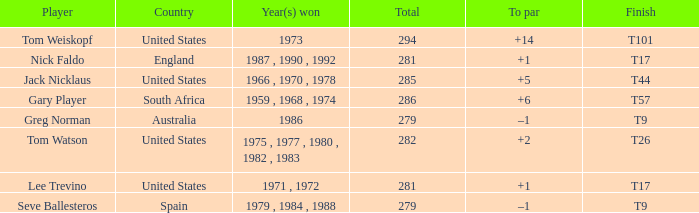What is Australia's to par? –1. 